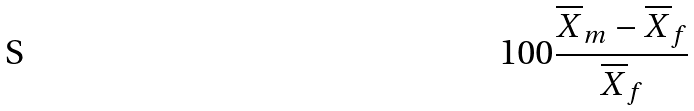Convert formula to latex. <formula><loc_0><loc_0><loc_500><loc_500>1 0 0 \frac { \overline { X } _ { m } - \overline { X } _ { f } } { \overline { X } _ { f } }</formula> 